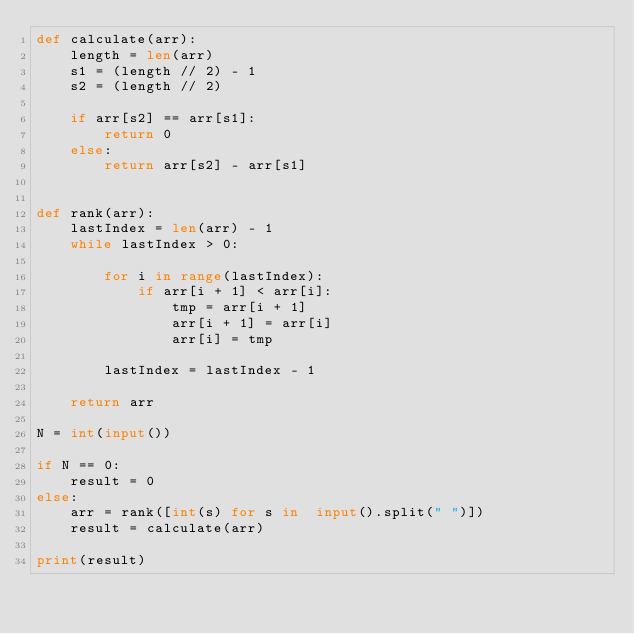Convert code to text. <code><loc_0><loc_0><loc_500><loc_500><_Python_>def calculate(arr):
    length = len(arr)
    s1 = (length // 2) - 1
    s2 = (length // 2)

    if arr[s2] == arr[s1]:
        return 0
    else:
        return arr[s2] - arr[s1]


def rank(arr):
    lastIndex = len(arr) - 1
    while lastIndex > 0:

        for i in range(lastIndex):
            if arr[i + 1] < arr[i]:
                tmp = arr[i + 1]
                arr[i + 1] = arr[i]
                arr[i] = tmp

        lastIndex = lastIndex - 1

    return arr

N = int(input())

if N == 0:
    result = 0
else:
    arr = rank([int(s) for s in  input().split(" ")])
    result = calculate(arr)

print(result)
</code> 